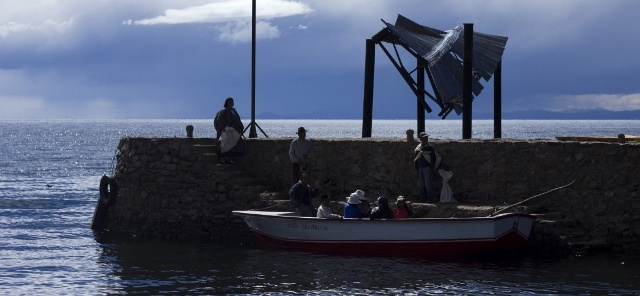Describe the objects in this image and their specific colors. I can see boat in lightgray, black, and gray tones, people in lightgray, black, gray, and darkblue tones, people in lightgray, black, gray, and darkgray tones, people in lightgray, black, and gray tones, and people in lightgray, black, gray, and darkgray tones in this image. 